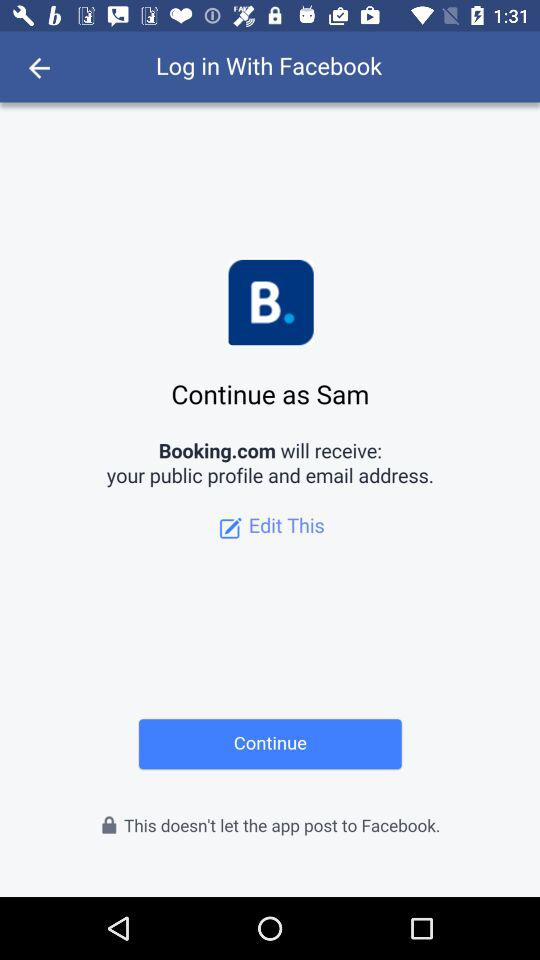What is the name of the user? The name of the user is Sam. 